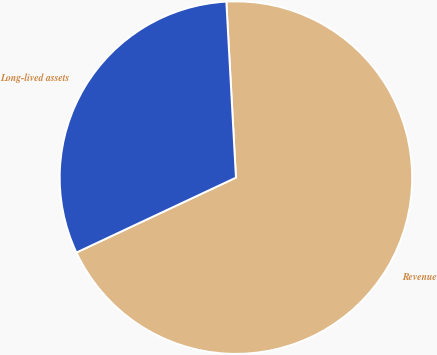<chart> <loc_0><loc_0><loc_500><loc_500><pie_chart><fcel>Revenue<fcel>Long-lived assets<nl><fcel>68.88%<fcel>31.12%<nl></chart> 